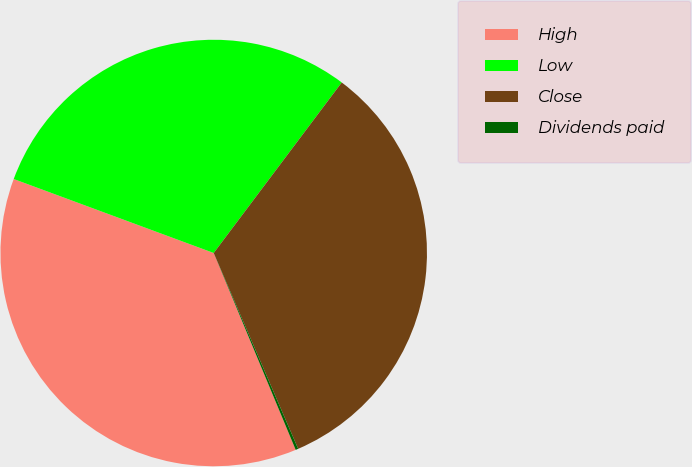Convert chart. <chart><loc_0><loc_0><loc_500><loc_500><pie_chart><fcel>High<fcel>Low<fcel>Close<fcel>Dividends paid<nl><fcel>36.92%<fcel>29.61%<fcel>33.27%<fcel>0.2%<nl></chart> 